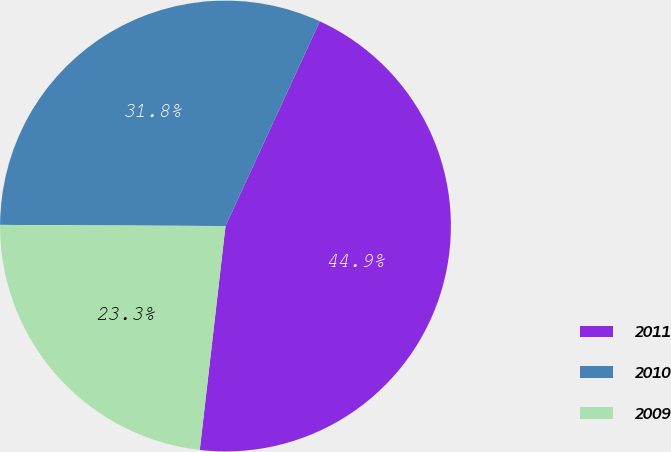Convert chart to OTSL. <chart><loc_0><loc_0><loc_500><loc_500><pie_chart><fcel>2011<fcel>2010<fcel>2009<nl><fcel>44.95%<fcel>31.79%<fcel>23.26%<nl></chart> 